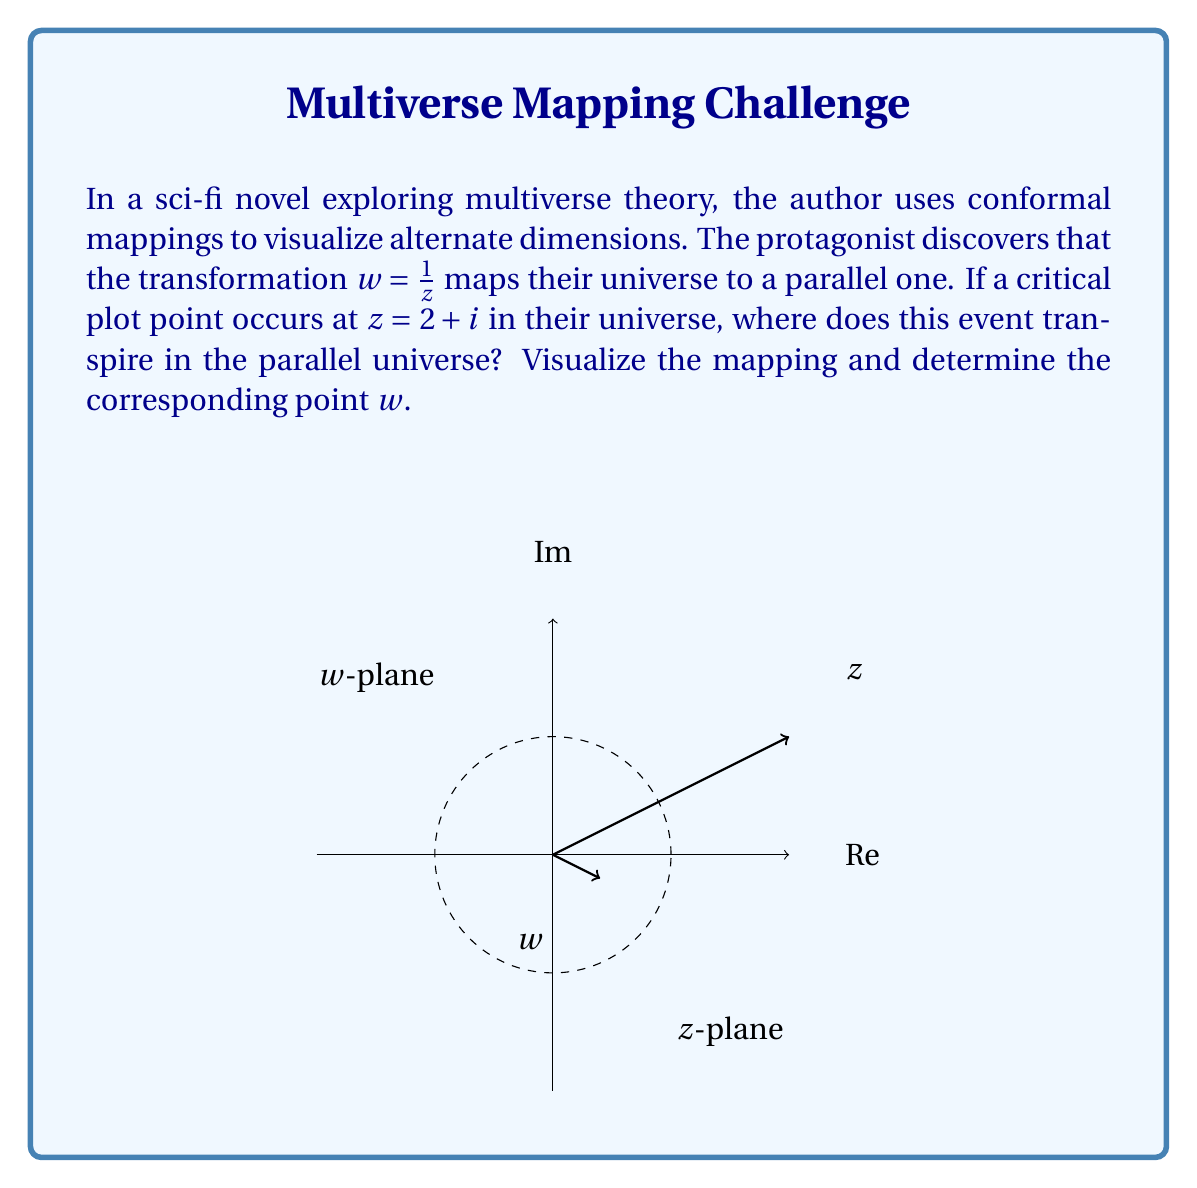What is the answer to this math problem? Let's approach this step-by-step:

1) The given conformal mapping is $w = \frac{1}{z}$. This is known as the complex inversion or reciprocal transformation.

2) We need to find $w$ when $z = 2 + i$. Let's substitute this into our mapping function:

   $w = \frac{1}{z} = \frac{1}{2 + i}$

3) To simplify this, we need to rationalize the denominator. We multiply both numerator and denominator by the complex conjugate of the denominator:

   $w = \frac{1}{2 + i} \cdot \frac{2 - i}{2 - i} = \frac{2 - i}{(2 + i)(2 - i)} = \frac{2 - i}{4 + 1} = \frac{2 - i}{5}$

4) Now, let's separate the real and imaginary parts:

   $w = \frac{2}{5} - \frac{1}{5}i$

5) To visualize this, we can observe that:
   - The original point $z = 2 + i$ is outside the unit circle in the $z$-plane.
   - Its image $w = \frac{2}{5} - \frac{1}{5}i$ is inside the unit circle in the $w$-plane.
   - The inversion transformation maps points outside the unit circle to points inside it, and vice versa.

6) The magnitude of $w$ can be calculated:

   $|w| = \sqrt{(\frac{2}{5})^2 + (-\frac{1}{5})^2} = \frac{\sqrt{5}}{5} = \frac{1}{\sqrt{5}} \approx 0.447$

   This confirms that $w$ is indeed inside the unit circle.

This transformation effectively "flips" the universe inside-out, with events far from the origin in one universe occurring close to the origin in the other, providing an intriguing visualization of a parallel universe for the sci-fi plot.
Answer: $w = \frac{2}{5} - \frac{1}{5}i$ 